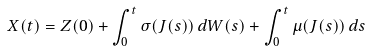Convert formula to latex. <formula><loc_0><loc_0><loc_500><loc_500>X ( t ) = Z ( 0 ) + \int _ { 0 } ^ { t } \sigma ( J ( s ) ) \, d W ( s ) + \int _ { 0 } ^ { t } \mu ( J ( s ) ) \, d s</formula> 